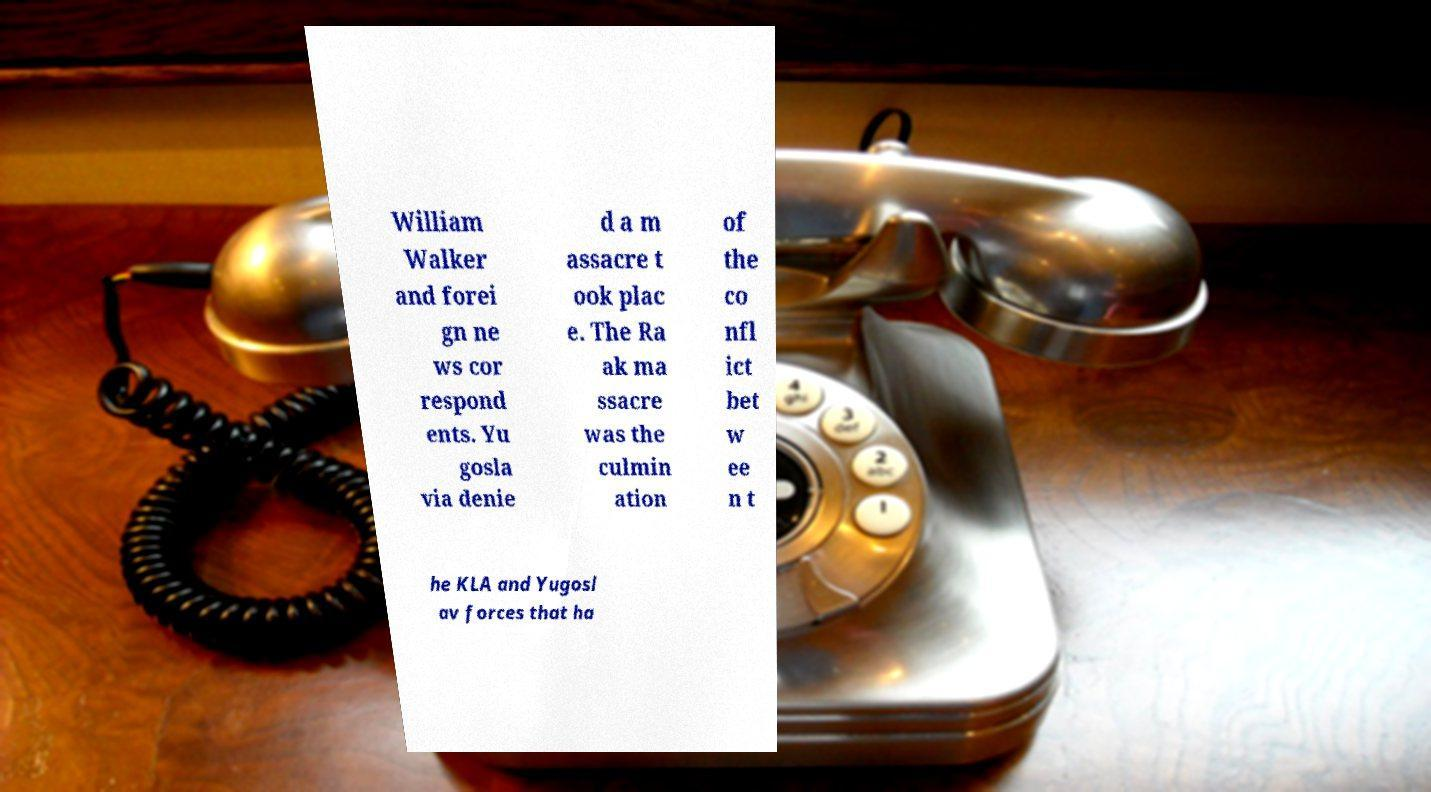I need the written content from this picture converted into text. Can you do that? William Walker and forei gn ne ws cor respond ents. Yu gosla via denie d a m assacre t ook plac e. The Ra ak ma ssacre was the culmin ation of the co nfl ict bet w ee n t he KLA and Yugosl av forces that ha 